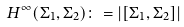Convert formula to latex. <formula><loc_0><loc_0><loc_500><loc_500>H ^ { \infty } ( \Sigma _ { 1 } , \Sigma _ { 2 } ) \colon = \left | [ \Sigma _ { 1 } , \Sigma _ { 2 } ] \right |</formula> 